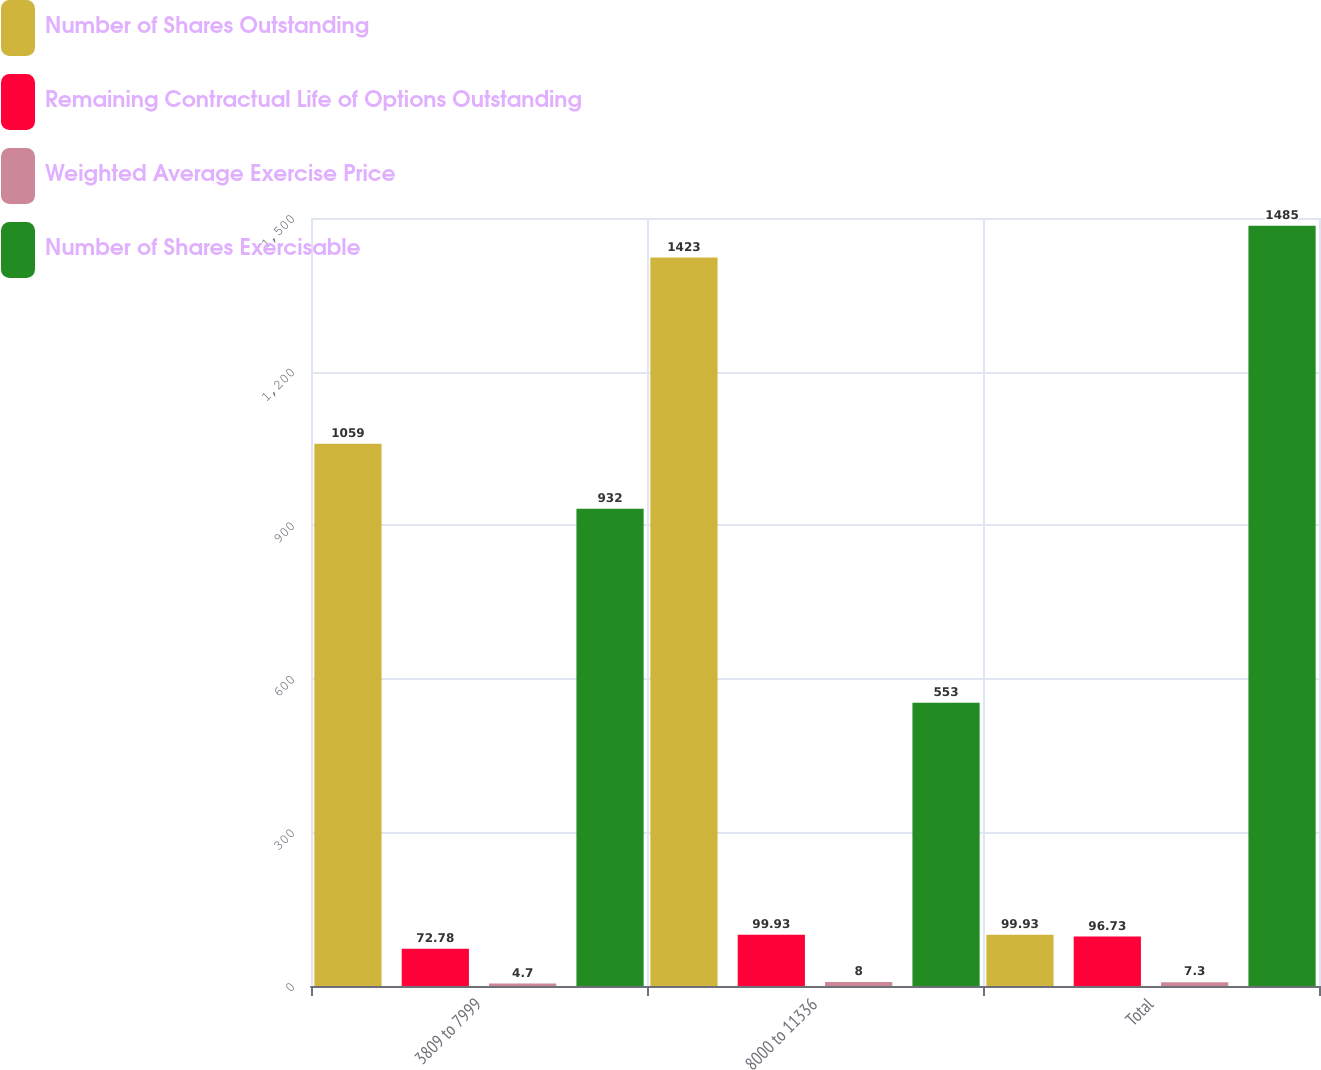Convert chart to OTSL. <chart><loc_0><loc_0><loc_500><loc_500><stacked_bar_chart><ecel><fcel>3809 to 7999<fcel>8000 to 11336<fcel>Total<nl><fcel>Number of Shares Outstanding<fcel>1059<fcel>1423<fcel>99.93<nl><fcel>Remaining Contractual Life of Options Outstanding<fcel>72.78<fcel>99.93<fcel>96.73<nl><fcel>Weighted Average Exercise Price<fcel>4.7<fcel>8<fcel>7.3<nl><fcel>Number of Shares Exercisable<fcel>932<fcel>553<fcel>1485<nl></chart> 